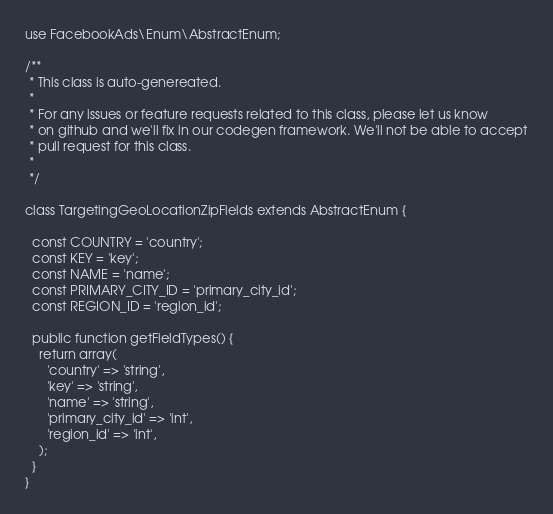Convert code to text. <code><loc_0><loc_0><loc_500><loc_500><_PHP_>use FacebookAds\Enum\AbstractEnum;

/**
 * This class is auto-genereated.
 *
 * For any issues or feature requests related to this class, please let us know
 * on github and we'll fix in our codegen framework. We'll not be able to accept
 * pull request for this class.
 *
 */

class TargetingGeoLocationZipFields extends AbstractEnum {

  const COUNTRY = 'country';
  const KEY = 'key';
  const NAME = 'name';
  const PRIMARY_CITY_ID = 'primary_city_id';
  const REGION_ID = 'region_id';

  public function getFieldTypes() {
    return array(
      'country' => 'string',
      'key' => 'string',
      'name' => 'string',
      'primary_city_id' => 'int',
      'region_id' => 'int',
    );
  }
}
</code> 